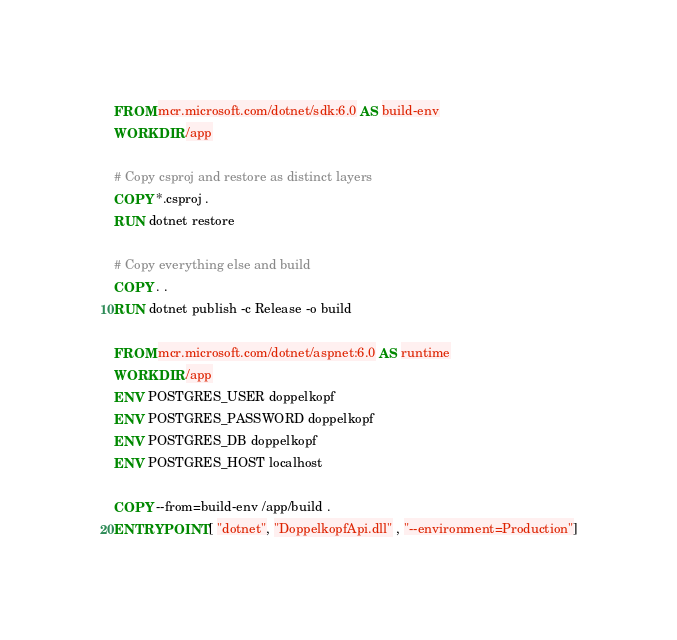<code> <loc_0><loc_0><loc_500><loc_500><_Dockerfile_>FROM mcr.microsoft.com/dotnet/sdk:6.0 AS build-env
WORKDIR /app

# Copy csproj and restore as distinct layers
COPY *.csproj .
RUN dotnet restore

# Copy everything else and build
COPY . .
RUN dotnet publish -c Release -o build

FROM mcr.microsoft.com/dotnet/aspnet:6.0 AS runtime
WORKDIR /app
ENV POSTGRES_USER doppelkopf
ENV POSTGRES_PASSWORD doppelkopf
ENV POSTGRES_DB doppelkopf
ENV POSTGRES_HOST localhost

COPY --from=build-env /app/build .
ENTRYPOINT [ "dotnet", "DoppelkopfApi.dll" , "--environment=Production"]
</code> 